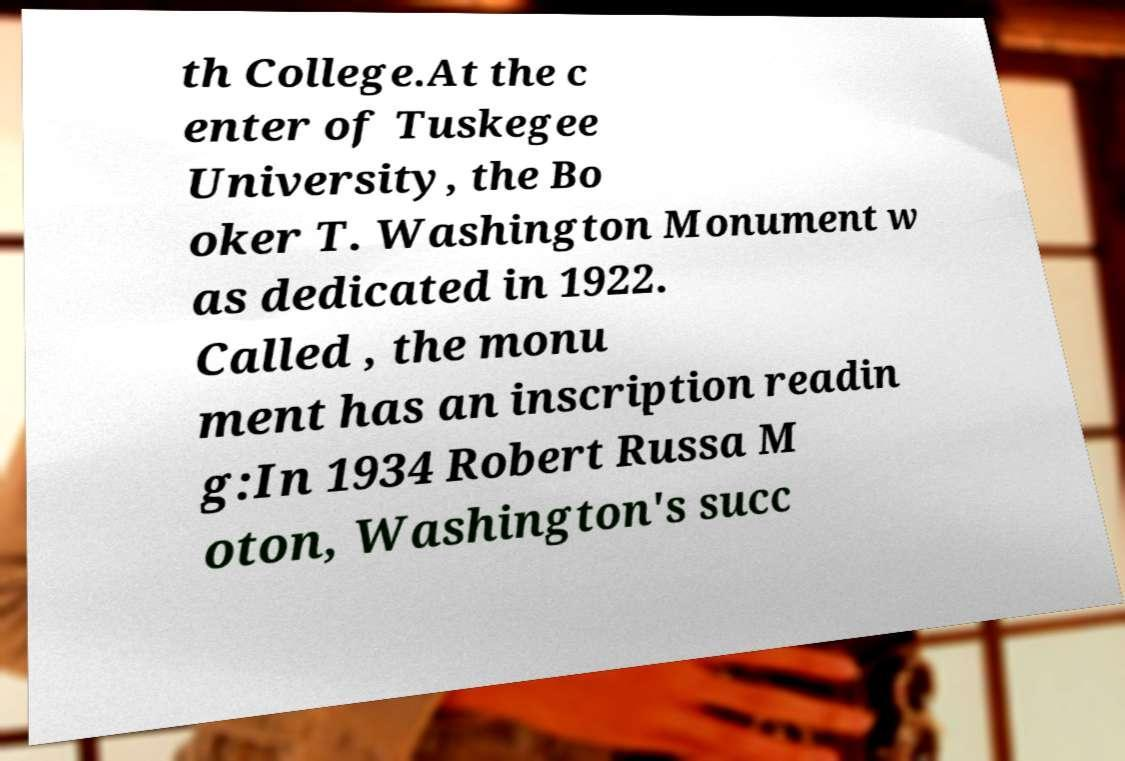Could you assist in decoding the text presented in this image and type it out clearly? th College.At the c enter of Tuskegee University, the Bo oker T. Washington Monument w as dedicated in 1922. Called , the monu ment has an inscription readin g:In 1934 Robert Russa M oton, Washington's succ 